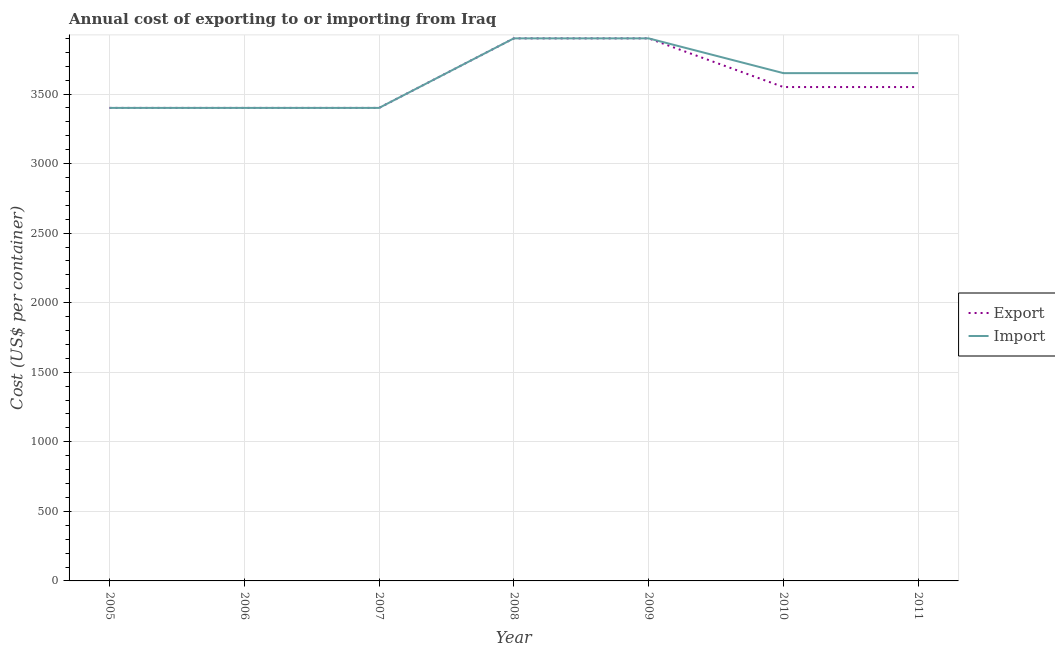Is the number of lines equal to the number of legend labels?
Your answer should be compact. Yes. What is the export cost in 2005?
Provide a succinct answer. 3400. Across all years, what is the maximum export cost?
Offer a terse response. 3900. Across all years, what is the minimum export cost?
Your answer should be compact. 3400. In which year was the import cost minimum?
Give a very brief answer. 2005. What is the total import cost in the graph?
Make the answer very short. 2.53e+04. What is the difference between the export cost in 2007 and that in 2011?
Offer a very short reply. -150. What is the difference between the export cost in 2010 and the import cost in 2005?
Offer a terse response. 150. What is the average import cost per year?
Make the answer very short. 3614.29. In the year 2009, what is the difference between the export cost and import cost?
Make the answer very short. 0. In how many years, is the export cost greater than 3000 US$?
Ensure brevity in your answer.  7. What is the ratio of the import cost in 2006 to that in 2009?
Make the answer very short. 0.87. Is the difference between the export cost in 2008 and 2010 greater than the difference between the import cost in 2008 and 2010?
Ensure brevity in your answer.  Yes. What is the difference between the highest and the lowest export cost?
Ensure brevity in your answer.  500. In how many years, is the export cost greater than the average export cost taken over all years?
Provide a succinct answer. 2. Is the sum of the import cost in 2006 and 2011 greater than the maximum export cost across all years?
Your answer should be very brief. Yes. Does the export cost monotonically increase over the years?
Your answer should be very brief. No. Is the export cost strictly greater than the import cost over the years?
Ensure brevity in your answer.  No. How many lines are there?
Make the answer very short. 2. How many years are there in the graph?
Give a very brief answer. 7. What is the difference between two consecutive major ticks on the Y-axis?
Your response must be concise. 500. What is the title of the graph?
Offer a terse response. Annual cost of exporting to or importing from Iraq. Does "Central government" appear as one of the legend labels in the graph?
Offer a very short reply. No. What is the label or title of the Y-axis?
Ensure brevity in your answer.  Cost (US$ per container). What is the Cost (US$ per container) of Export in 2005?
Offer a terse response. 3400. What is the Cost (US$ per container) of Import in 2005?
Your answer should be very brief. 3400. What is the Cost (US$ per container) of Export in 2006?
Make the answer very short. 3400. What is the Cost (US$ per container) in Import in 2006?
Provide a succinct answer. 3400. What is the Cost (US$ per container) in Export in 2007?
Make the answer very short. 3400. What is the Cost (US$ per container) in Import in 2007?
Offer a very short reply. 3400. What is the Cost (US$ per container) of Export in 2008?
Make the answer very short. 3900. What is the Cost (US$ per container) of Import in 2008?
Keep it short and to the point. 3900. What is the Cost (US$ per container) in Export in 2009?
Give a very brief answer. 3900. What is the Cost (US$ per container) in Import in 2009?
Keep it short and to the point. 3900. What is the Cost (US$ per container) of Export in 2010?
Your response must be concise. 3550. What is the Cost (US$ per container) of Import in 2010?
Provide a short and direct response. 3650. What is the Cost (US$ per container) in Export in 2011?
Offer a terse response. 3550. What is the Cost (US$ per container) in Import in 2011?
Offer a very short reply. 3650. Across all years, what is the maximum Cost (US$ per container) of Export?
Your response must be concise. 3900. Across all years, what is the maximum Cost (US$ per container) of Import?
Offer a terse response. 3900. Across all years, what is the minimum Cost (US$ per container) in Export?
Ensure brevity in your answer.  3400. Across all years, what is the minimum Cost (US$ per container) in Import?
Ensure brevity in your answer.  3400. What is the total Cost (US$ per container) in Export in the graph?
Provide a short and direct response. 2.51e+04. What is the total Cost (US$ per container) of Import in the graph?
Make the answer very short. 2.53e+04. What is the difference between the Cost (US$ per container) in Import in 2005 and that in 2006?
Make the answer very short. 0. What is the difference between the Cost (US$ per container) in Import in 2005 and that in 2007?
Keep it short and to the point. 0. What is the difference between the Cost (US$ per container) of Export in 2005 and that in 2008?
Keep it short and to the point. -500. What is the difference between the Cost (US$ per container) of Import in 2005 and that in 2008?
Provide a short and direct response. -500. What is the difference between the Cost (US$ per container) of Export in 2005 and that in 2009?
Provide a succinct answer. -500. What is the difference between the Cost (US$ per container) of Import in 2005 and that in 2009?
Offer a very short reply. -500. What is the difference between the Cost (US$ per container) in Export in 2005 and that in 2010?
Give a very brief answer. -150. What is the difference between the Cost (US$ per container) in Import in 2005 and that in 2010?
Your response must be concise. -250. What is the difference between the Cost (US$ per container) of Export in 2005 and that in 2011?
Make the answer very short. -150. What is the difference between the Cost (US$ per container) in Import in 2005 and that in 2011?
Your answer should be compact. -250. What is the difference between the Cost (US$ per container) in Import in 2006 and that in 2007?
Offer a very short reply. 0. What is the difference between the Cost (US$ per container) of Export in 2006 and that in 2008?
Your response must be concise. -500. What is the difference between the Cost (US$ per container) of Import in 2006 and that in 2008?
Offer a very short reply. -500. What is the difference between the Cost (US$ per container) of Export in 2006 and that in 2009?
Your answer should be compact. -500. What is the difference between the Cost (US$ per container) of Import in 2006 and that in 2009?
Give a very brief answer. -500. What is the difference between the Cost (US$ per container) in Export in 2006 and that in 2010?
Offer a very short reply. -150. What is the difference between the Cost (US$ per container) of Import in 2006 and that in 2010?
Provide a short and direct response. -250. What is the difference between the Cost (US$ per container) of Export in 2006 and that in 2011?
Provide a succinct answer. -150. What is the difference between the Cost (US$ per container) in Import in 2006 and that in 2011?
Keep it short and to the point. -250. What is the difference between the Cost (US$ per container) of Export in 2007 and that in 2008?
Your response must be concise. -500. What is the difference between the Cost (US$ per container) of Import in 2007 and that in 2008?
Provide a short and direct response. -500. What is the difference between the Cost (US$ per container) of Export in 2007 and that in 2009?
Your answer should be compact. -500. What is the difference between the Cost (US$ per container) in Import in 2007 and that in 2009?
Your answer should be compact. -500. What is the difference between the Cost (US$ per container) in Export in 2007 and that in 2010?
Your answer should be compact. -150. What is the difference between the Cost (US$ per container) in Import in 2007 and that in 2010?
Give a very brief answer. -250. What is the difference between the Cost (US$ per container) in Export in 2007 and that in 2011?
Keep it short and to the point. -150. What is the difference between the Cost (US$ per container) in Import in 2007 and that in 2011?
Make the answer very short. -250. What is the difference between the Cost (US$ per container) in Export in 2008 and that in 2009?
Ensure brevity in your answer.  0. What is the difference between the Cost (US$ per container) in Export in 2008 and that in 2010?
Ensure brevity in your answer.  350. What is the difference between the Cost (US$ per container) in Import in 2008 and that in 2010?
Your response must be concise. 250. What is the difference between the Cost (US$ per container) in Export in 2008 and that in 2011?
Make the answer very short. 350. What is the difference between the Cost (US$ per container) in Import in 2008 and that in 2011?
Provide a short and direct response. 250. What is the difference between the Cost (US$ per container) of Export in 2009 and that in 2010?
Ensure brevity in your answer.  350. What is the difference between the Cost (US$ per container) in Import in 2009 and that in 2010?
Make the answer very short. 250. What is the difference between the Cost (US$ per container) of Export in 2009 and that in 2011?
Offer a very short reply. 350. What is the difference between the Cost (US$ per container) in Import in 2009 and that in 2011?
Give a very brief answer. 250. What is the difference between the Cost (US$ per container) in Export in 2010 and that in 2011?
Make the answer very short. 0. What is the difference between the Cost (US$ per container) of Import in 2010 and that in 2011?
Offer a terse response. 0. What is the difference between the Cost (US$ per container) in Export in 2005 and the Cost (US$ per container) in Import in 2006?
Keep it short and to the point. 0. What is the difference between the Cost (US$ per container) in Export in 2005 and the Cost (US$ per container) in Import in 2008?
Make the answer very short. -500. What is the difference between the Cost (US$ per container) of Export in 2005 and the Cost (US$ per container) of Import in 2009?
Give a very brief answer. -500. What is the difference between the Cost (US$ per container) in Export in 2005 and the Cost (US$ per container) in Import in 2010?
Provide a short and direct response. -250. What is the difference between the Cost (US$ per container) of Export in 2005 and the Cost (US$ per container) of Import in 2011?
Your response must be concise. -250. What is the difference between the Cost (US$ per container) in Export in 2006 and the Cost (US$ per container) in Import in 2007?
Give a very brief answer. 0. What is the difference between the Cost (US$ per container) in Export in 2006 and the Cost (US$ per container) in Import in 2008?
Your response must be concise. -500. What is the difference between the Cost (US$ per container) in Export in 2006 and the Cost (US$ per container) in Import in 2009?
Your answer should be compact. -500. What is the difference between the Cost (US$ per container) of Export in 2006 and the Cost (US$ per container) of Import in 2010?
Your response must be concise. -250. What is the difference between the Cost (US$ per container) in Export in 2006 and the Cost (US$ per container) in Import in 2011?
Your answer should be compact. -250. What is the difference between the Cost (US$ per container) in Export in 2007 and the Cost (US$ per container) in Import in 2008?
Offer a very short reply. -500. What is the difference between the Cost (US$ per container) in Export in 2007 and the Cost (US$ per container) in Import in 2009?
Give a very brief answer. -500. What is the difference between the Cost (US$ per container) in Export in 2007 and the Cost (US$ per container) in Import in 2010?
Provide a short and direct response. -250. What is the difference between the Cost (US$ per container) of Export in 2007 and the Cost (US$ per container) of Import in 2011?
Give a very brief answer. -250. What is the difference between the Cost (US$ per container) in Export in 2008 and the Cost (US$ per container) in Import in 2010?
Your answer should be very brief. 250. What is the difference between the Cost (US$ per container) in Export in 2008 and the Cost (US$ per container) in Import in 2011?
Keep it short and to the point. 250. What is the difference between the Cost (US$ per container) in Export in 2009 and the Cost (US$ per container) in Import in 2010?
Give a very brief answer. 250. What is the difference between the Cost (US$ per container) of Export in 2009 and the Cost (US$ per container) of Import in 2011?
Give a very brief answer. 250. What is the difference between the Cost (US$ per container) in Export in 2010 and the Cost (US$ per container) in Import in 2011?
Give a very brief answer. -100. What is the average Cost (US$ per container) in Export per year?
Provide a short and direct response. 3585.71. What is the average Cost (US$ per container) in Import per year?
Your answer should be compact. 3614.29. In the year 2005, what is the difference between the Cost (US$ per container) in Export and Cost (US$ per container) in Import?
Provide a short and direct response. 0. In the year 2007, what is the difference between the Cost (US$ per container) of Export and Cost (US$ per container) of Import?
Keep it short and to the point. 0. In the year 2008, what is the difference between the Cost (US$ per container) of Export and Cost (US$ per container) of Import?
Keep it short and to the point. 0. In the year 2009, what is the difference between the Cost (US$ per container) of Export and Cost (US$ per container) of Import?
Offer a very short reply. 0. In the year 2010, what is the difference between the Cost (US$ per container) of Export and Cost (US$ per container) of Import?
Your response must be concise. -100. In the year 2011, what is the difference between the Cost (US$ per container) of Export and Cost (US$ per container) of Import?
Offer a terse response. -100. What is the ratio of the Cost (US$ per container) of Import in 2005 to that in 2006?
Keep it short and to the point. 1. What is the ratio of the Cost (US$ per container) of Export in 2005 to that in 2007?
Give a very brief answer. 1. What is the ratio of the Cost (US$ per container) in Export in 2005 to that in 2008?
Offer a very short reply. 0.87. What is the ratio of the Cost (US$ per container) in Import in 2005 to that in 2008?
Your response must be concise. 0.87. What is the ratio of the Cost (US$ per container) of Export in 2005 to that in 2009?
Keep it short and to the point. 0.87. What is the ratio of the Cost (US$ per container) in Import in 2005 to that in 2009?
Keep it short and to the point. 0.87. What is the ratio of the Cost (US$ per container) in Export in 2005 to that in 2010?
Provide a succinct answer. 0.96. What is the ratio of the Cost (US$ per container) of Import in 2005 to that in 2010?
Give a very brief answer. 0.93. What is the ratio of the Cost (US$ per container) of Export in 2005 to that in 2011?
Make the answer very short. 0.96. What is the ratio of the Cost (US$ per container) of Import in 2005 to that in 2011?
Your answer should be very brief. 0.93. What is the ratio of the Cost (US$ per container) in Export in 2006 to that in 2007?
Your answer should be compact. 1. What is the ratio of the Cost (US$ per container) in Export in 2006 to that in 2008?
Ensure brevity in your answer.  0.87. What is the ratio of the Cost (US$ per container) of Import in 2006 to that in 2008?
Provide a succinct answer. 0.87. What is the ratio of the Cost (US$ per container) of Export in 2006 to that in 2009?
Your response must be concise. 0.87. What is the ratio of the Cost (US$ per container) in Import in 2006 to that in 2009?
Provide a short and direct response. 0.87. What is the ratio of the Cost (US$ per container) of Export in 2006 to that in 2010?
Your answer should be very brief. 0.96. What is the ratio of the Cost (US$ per container) in Import in 2006 to that in 2010?
Give a very brief answer. 0.93. What is the ratio of the Cost (US$ per container) of Export in 2006 to that in 2011?
Ensure brevity in your answer.  0.96. What is the ratio of the Cost (US$ per container) in Import in 2006 to that in 2011?
Your answer should be very brief. 0.93. What is the ratio of the Cost (US$ per container) of Export in 2007 to that in 2008?
Your answer should be very brief. 0.87. What is the ratio of the Cost (US$ per container) in Import in 2007 to that in 2008?
Your answer should be very brief. 0.87. What is the ratio of the Cost (US$ per container) of Export in 2007 to that in 2009?
Provide a succinct answer. 0.87. What is the ratio of the Cost (US$ per container) in Import in 2007 to that in 2009?
Offer a terse response. 0.87. What is the ratio of the Cost (US$ per container) in Export in 2007 to that in 2010?
Your answer should be very brief. 0.96. What is the ratio of the Cost (US$ per container) in Import in 2007 to that in 2010?
Provide a succinct answer. 0.93. What is the ratio of the Cost (US$ per container) of Export in 2007 to that in 2011?
Give a very brief answer. 0.96. What is the ratio of the Cost (US$ per container) in Import in 2007 to that in 2011?
Make the answer very short. 0.93. What is the ratio of the Cost (US$ per container) in Export in 2008 to that in 2009?
Make the answer very short. 1. What is the ratio of the Cost (US$ per container) in Import in 2008 to that in 2009?
Ensure brevity in your answer.  1. What is the ratio of the Cost (US$ per container) of Export in 2008 to that in 2010?
Make the answer very short. 1.1. What is the ratio of the Cost (US$ per container) of Import in 2008 to that in 2010?
Your answer should be compact. 1.07. What is the ratio of the Cost (US$ per container) of Export in 2008 to that in 2011?
Provide a succinct answer. 1.1. What is the ratio of the Cost (US$ per container) of Import in 2008 to that in 2011?
Offer a very short reply. 1.07. What is the ratio of the Cost (US$ per container) in Export in 2009 to that in 2010?
Keep it short and to the point. 1.1. What is the ratio of the Cost (US$ per container) in Import in 2009 to that in 2010?
Provide a short and direct response. 1.07. What is the ratio of the Cost (US$ per container) in Export in 2009 to that in 2011?
Offer a very short reply. 1.1. What is the ratio of the Cost (US$ per container) in Import in 2009 to that in 2011?
Your answer should be compact. 1.07. What is the difference between the highest and the second highest Cost (US$ per container) of Export?
Offer a very short reply. 0. What is the difference between the highest and the lowest Cost (US$ per container) in Export?
Give a very brief answer. 500. What is the difference between the highest and the lowest Cost (US$ per container) in Import?
Offer a terse response. 500. 